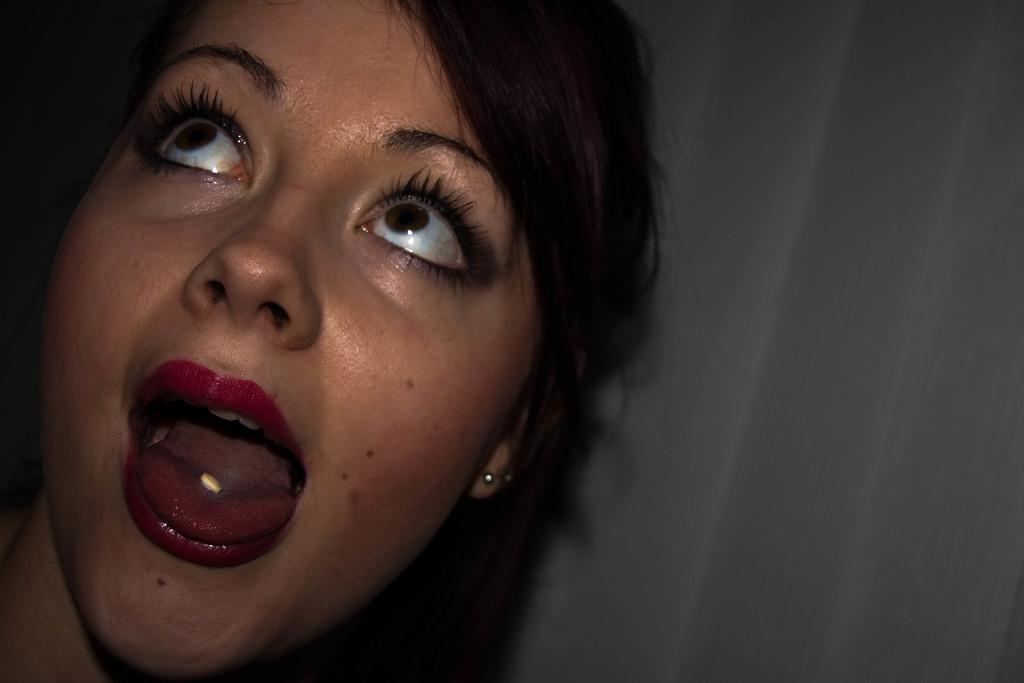Who is present in the image? There is a woman in the image. What object is the woman holding in her mouth? The woman has a tablet in her mouth. What can be seen in the background of the image? There is a wall visible in the image. What time of day is it in the image, and is there a train visible? The time of day is not mentioned in the image, and there is no train visible. 